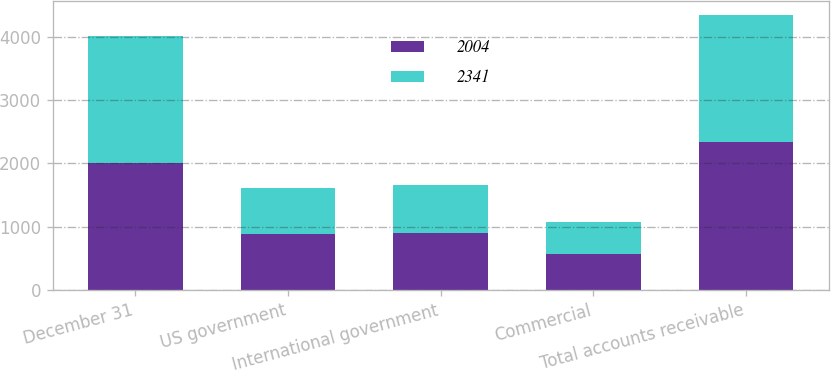Convert chart to OTSL. <chart><loc_0><loc_0><loc_500><loc_500><stacked_bar_chart><ecel><fcel>December 31<fcel>US government<fcel>International government<fcel>Commercial<fcel>Total accounts receivable<nl><fcel>2004<fcel>2006<fcel>877<fcel>896<fcel>568<fcel>2341<nl><fcel>2341<fcel>2005<fcel>736<fcel>757<fcel>511<fcel>2004<nl></chart> 